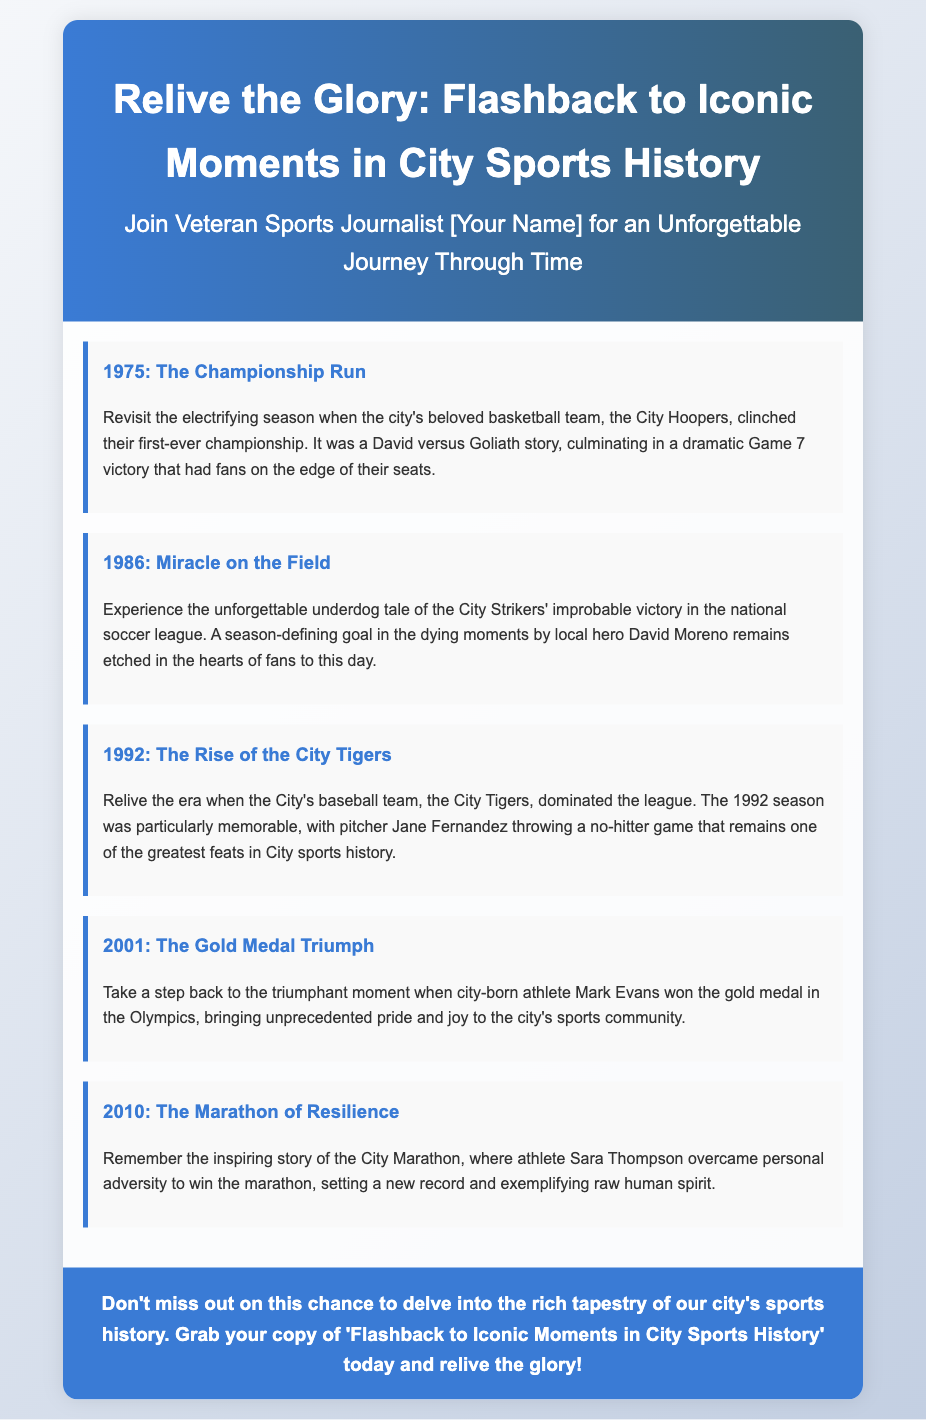What year did the City Hoopers win their first championship? The document states that the City Hoopers won their first-ever championship in 1975.
Answer: 1975 Who is the local hero mentioned in the 1986 moment? The document highlights David Moreno as the local hero who scored the season-defining goal in 1986.
Answer: David Moreno What is the title of the book being advertised? The title of the book, as mentioned in the advertisement, is 'Flashback to Iconic Moments in City Sports History'.
Answer: Flashback to Iconic Moments in City Sports History In what year did Mark Evans win an Olympic gold medal? According to the document, Mark Evans won the Olympic gold medal in 2001.
Answer: 2001 Which team is associated with the no-hitter game in 1992? The City Tigers are mentioned as the team associated with the no-hitter game thrown by Jane Fernandez in 1992.
Answer: City Tigers What is the main theme of the advertisement? The advertisement focuses on reliving iconic moments in the city's sports history as explored in the book.
Answer: Reliving iconic moments in city sports history What personal challenge did Sara Thompson overcome in 2010? The document describes Sara Thompson overcoming personal adversity to win the marathon in 2010.
Answer: Personal adversity How does the advertisement encourage readers to engage with the book? The advertisement concludes with a call to action urging readers not to miss out on the chance to delve into the city’s sports history.
Answer: Call to action What significant achievement is highlighted in the 2001 moment? The document highlights Mark Evans winning a gold medal at the Olympics as a significant achievement in 2001.
Answer: Gold medal at the Olympics 